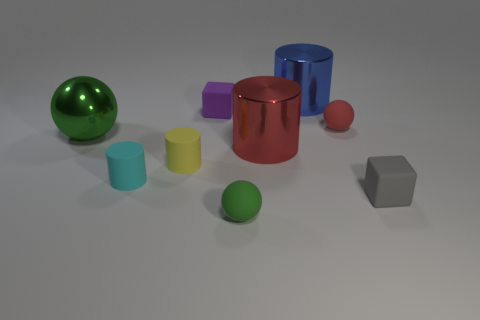There is a cylinder that is both to the right of the tiny yellow rubber cylinder and in front of the red matte sphere; what size is it?
Your answer should be very brief. Large. There is a blue cylinder behind the tiny red sphere right of the cube left of the small gray thing; what size is it?
Offer a very short reply. Large. Is there a big green shiny thing that has the same shape as the green matte object?
Provide a short and direct response. Yes. Is the material of the gray block the same as the block on the left side of the blue metal cylinder?
Keep it short and to the point. Yes. Are there any things that have the same color as the big sphere?
Your answer should be compact. Yes. How many other things are made of the same material as the blue cylinder?
Keep it short and to the point. 2. Does the big metallic ball have the same color as the small ball in front of the gray object?
Provide a succinct answer. Yes. Are there more tiny rubber objects behind the cyan cylinder than red rubber objects?
Offer a very short reply. Yes. What number of small blocks are behind the tiny cube in front of the tiny block that is behind the red cylinder?
Give a very brief answer. 1. There is a big metallic thing that is on the right side of the large red metal object; is its shape the same as the small purple thing?
Your response must be concise. No. 